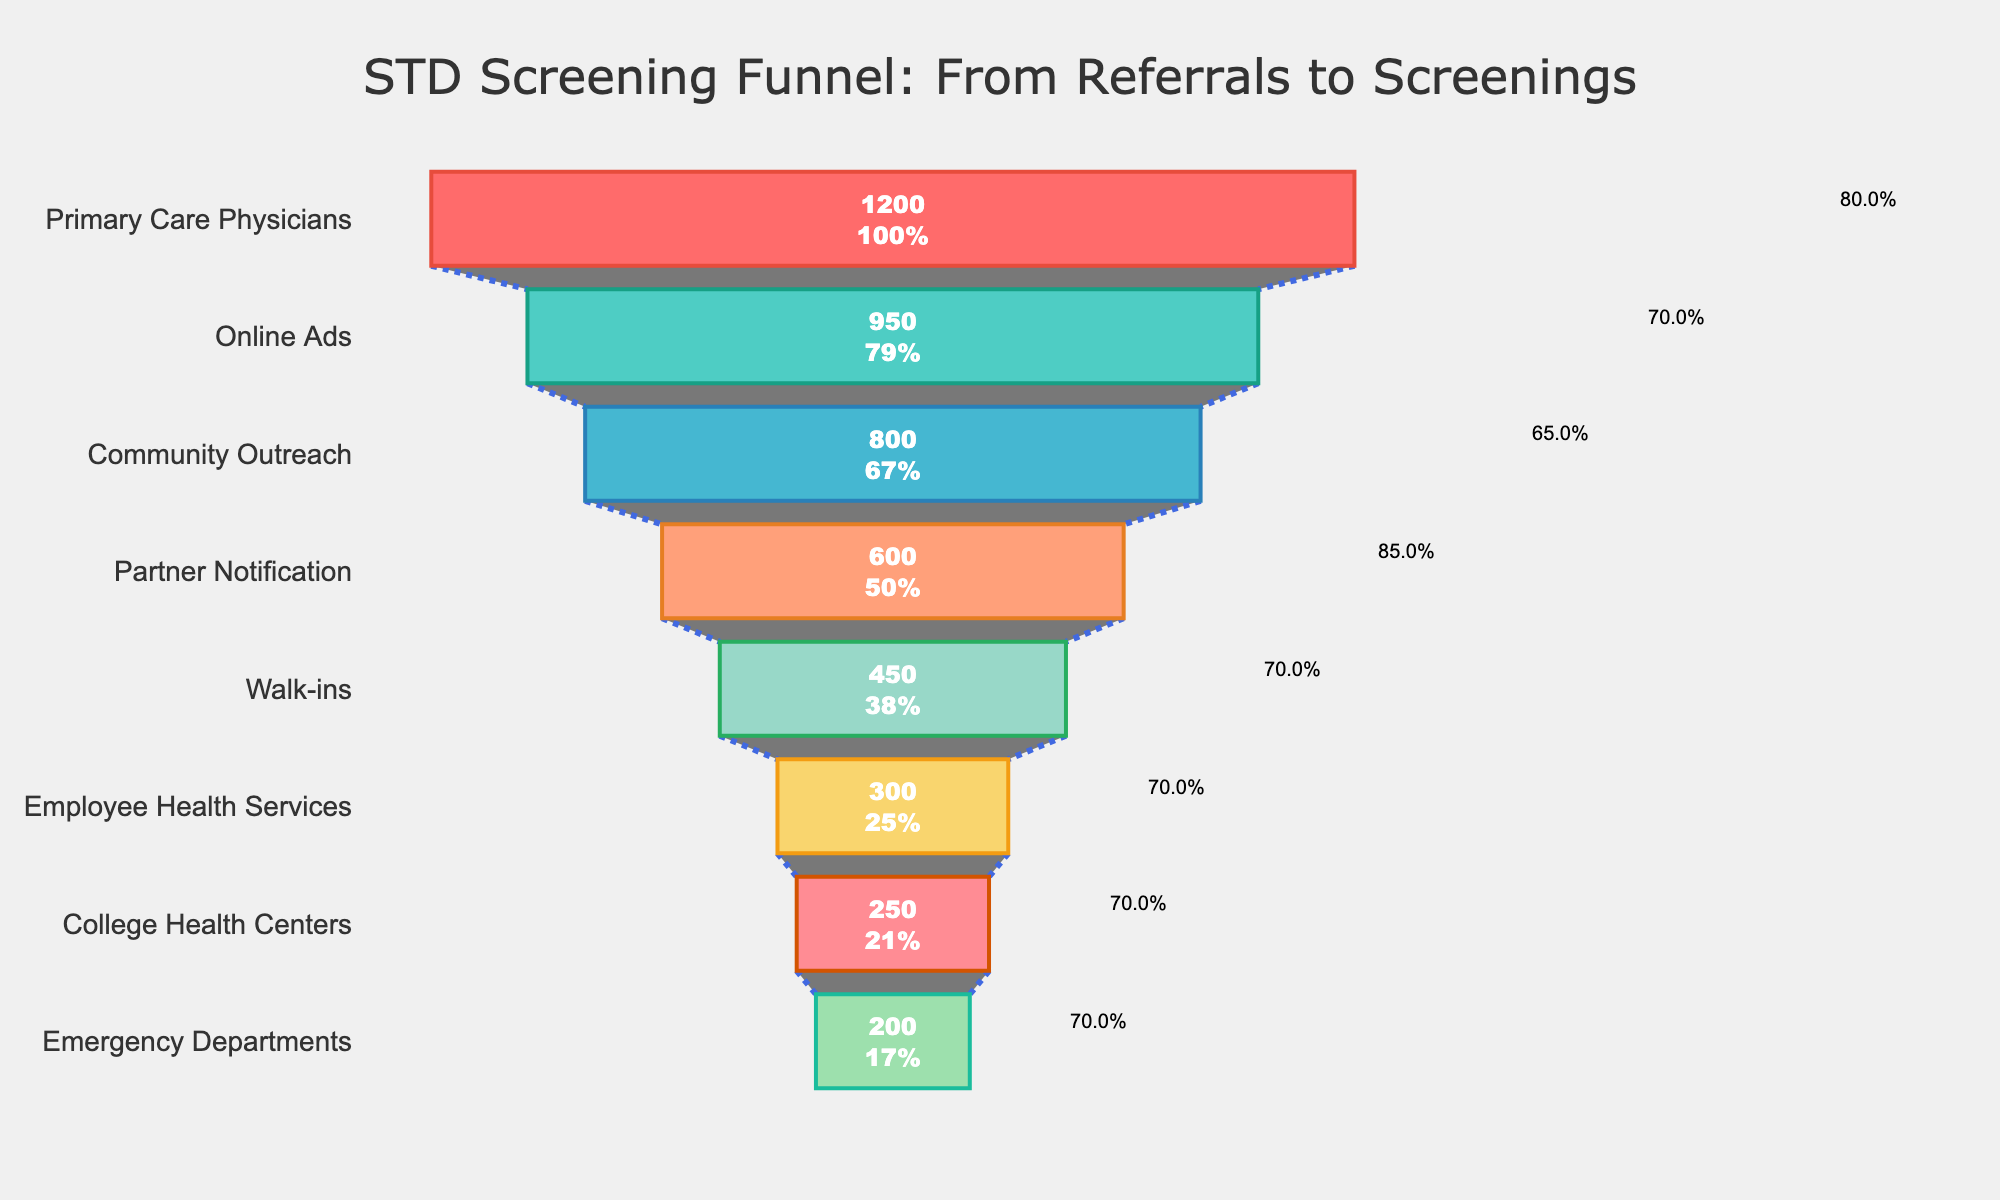What's the most common source of patient referrals for STD screenings? From the funnel chart, the source with the highest number of referrals is "Primary Care Physicians" as it is positioned at the top with the largest section.
Answer: "Primary Care Physicians" Which referral source has the highest conversion rate for STD screenings? The figure shows both referrals and conversion rates annotated on the funnel. "Partner Notification" has the highest conversion rate annotation of 85.0%.
Answer: "Partner Notification" How many patient referrals were there from Online Ads and Community Outreach combined? The number of referrals from "Online Ads" is 950 and from "Community Outreach" is 800. Adding these gives 950 + 800 = 1750 referrals.
Answer: 1750 In general, which sources have more than 50% conversion rates? To find the sources with more than 50% conversion rates, we look at the annotations beside each bar in the funnel chart. "Primary Care Physicians," "Online Ads," "Community Outreach," "Partner Notification," "Walk-ins," "Employee Health Services," and "College Health Centers" all have conversion rates greater than 50%.
Answer: "Primary Care Physicians," "Online Ads," "Community Outreach," "Partner Notification," "Walk-ins," "Employee Health Services," "College Health Centers" Which source has the lowest number of screenings, and what is that number? From the funnel chart, the source positioned at the bottom with the smallest section represents the lowest number of screenings. "Emergency Departments" have the lowest number of screenings, with 140.
Answer: 140 How many more referrals did "Primary Care Physicians" generate compared to "Walk-ins"? "Primary Care Physicians" had 1200 referrals, and "Walk-ins" had 450 referrals. The difference is 1200 - 450 = 750 referrals.
Answer: 750 Out of Employee Health Services and College Health Centers, which one has a higher conversion rate? The funnel chart shows conversion rates annotated next to the bars. "Employee Health Services" has a conversion rate of 70.0%, while "College Health Centers" have a conversion rate of 70.0%. Thus, they have the same conversion rate.
Answer: They have the same conversion rate What is the title of the funnel chart? The title of the funnel chart is displayed at the top of the figure and reads "STD Screening Funnel: From Referrals to Screenings."
Answer: "STD Screening Funnel: From Referrals to Screenings" How many sources are listed in the funnel chart? Counting the number of different sections (bars) in the funnel chart indicates the total number of sources listed. There are 8 sources shown in the chart.
Answer: 8 